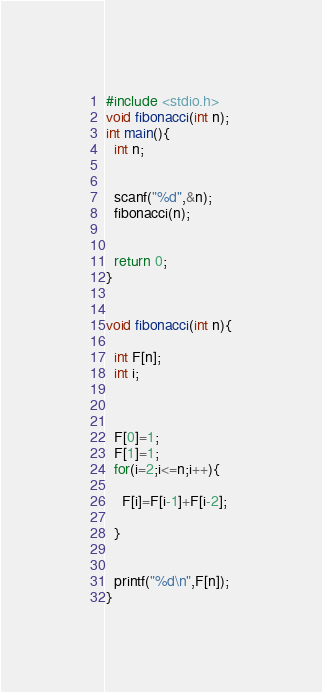Convert code to text. <code><loc_0><loc_0><loc_500><loc_500><_C_>#include <stdio.h>
void fibonacci(int n);
int main(){
  int n;
   
 
  scanf("%d",&n);
  fibonacci(n);

  
  return 0;
}


void fibonacci(int n){
  
  int F[n];
  int i;


  
  F[0]=1;
  F[1]=1;
  for(i=2;i<=n;i++){
    
    F[i]=F[i-1]+F[i-2];
    
  }

  
  printf("%d\n",F[n]);
}</code> 